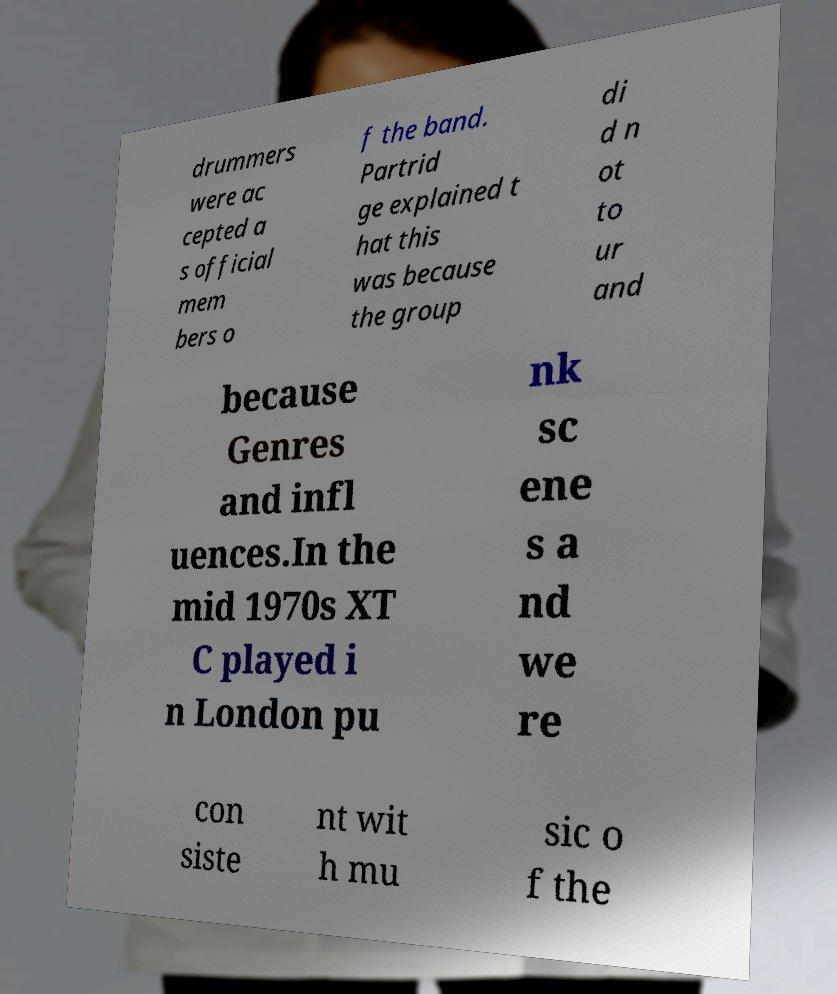Please identify and transcribe the text found in this image. drummers were ac cepted a s official mem bers o f the band. Partrid ge explained t hat this was because the group di d n ot to ur and because Genres and infl uences.In the mid 1970s XT C played i n London pu nk sc ene s a nd we re con siste nt wit h mu sic o f the 